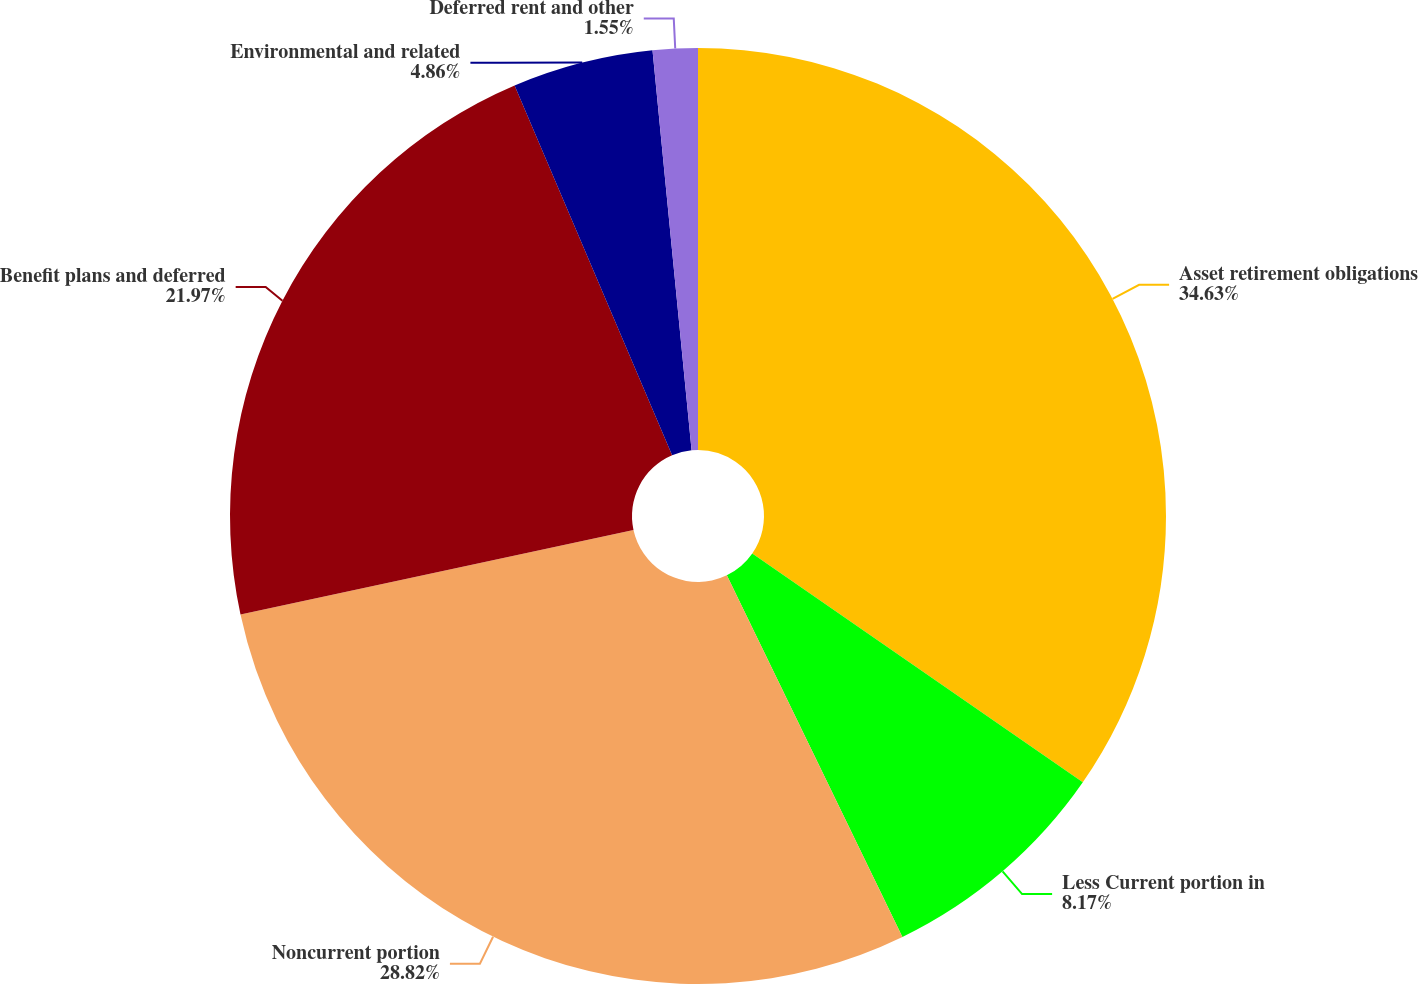Convert chart. <chart><loc_0><loc_0><loc_500><loc_500><pie_chart><fcel>Asset retirement obligations<fcel>Less Current portion in<fcel>Noncurrent portion<fcel>Benefit plans and deferred<fcel>Environmental and related<fcel>Deferred rent and other<nl><fcel>34.64%<fcel>8.17%<fcel>28.82%<fcel>21.97%<fcel>4.86%<fcel>1.55%<nl></chart> 